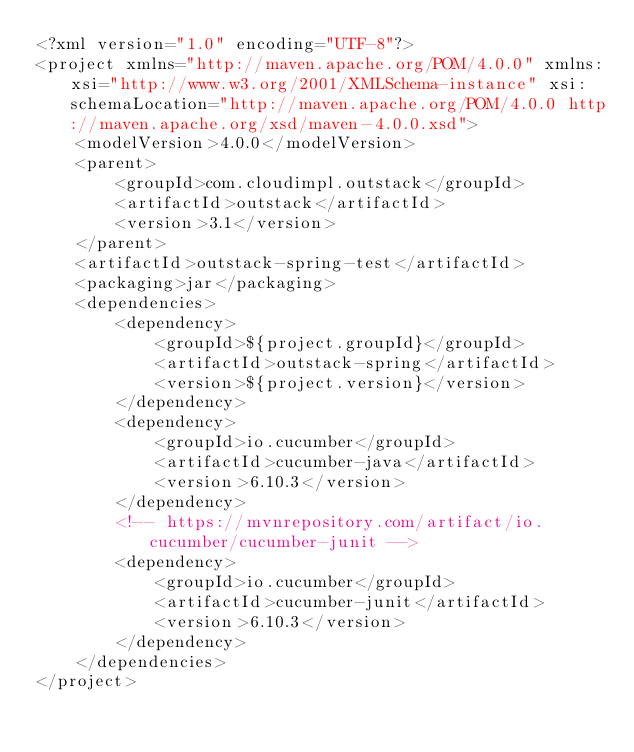Convert code to text. <code><loc_0><loc_0><loc_500><loc_500><_XML_><?xml version="1.0" encoding="UTF-8"?>
<project xmlns="http://maven.apache.org/POM/4.0.0" xmlns:xsi="http://www.w3.org/2001/XMLSchema-instance" xsi:schemaLocation="http://maven.apache.org/POM/4.0.0 http://maven.apache.org/xsd/maven-4.0.0.xsd">
    <modelVersion>4.0.0</modelVersion>
    <parent>
        <groupId>com.cloudimpl.outstack</groupId>
        <artifactId>outstack</artifactId>
        <version>3.1</version>
    </parent>
    <artifactId>outstack-spring-test</artifactId>
    <packaging>jar</packaging>
    <dependencies>
        <dependency>
            <groupId>${project.groupId}</groupId>
            <artifactId>outstack-spring</artifactId>
            <version>${project.version}</version>
        </dependency>
        <dependency>
            <groupId>io.cucumber</groupId>
            <artifactId>cucumber-java</artifactId>
            <version>6.10.3</version>
        </dependency>
        <!-- https://mvnrepository.com/artifact/io.cucumber/cucumber-junit -->
        <dependency>
            <groupId>io.cucumber</groupId>
            <artifactId>cucumber-junit</artifactId>
            <version>6.10.3</version>
        </dependency>
    </dependencies>
</project></code> 